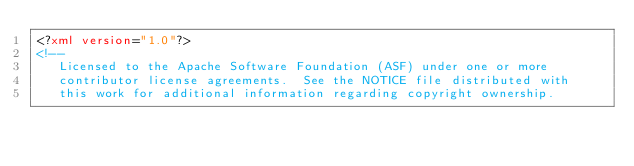<code> <loc_0><loc_0><loc_500><loc_500><_XML_><?xml version="1.0"?>
<!--
   Licensed to the Apache Software Foundation (ASF) under one or more
   contributor license agreements.  See the NOTICE file distributed with
   this work for additional information regarding copyright ownership.</code> 